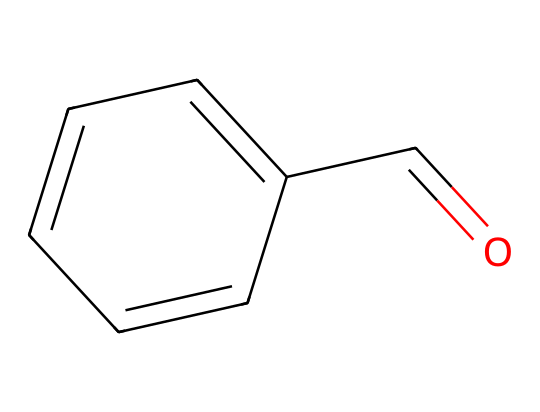What is the molecular formula of benzaldehyde? The molecular formula can be determined by counting each type of atom represented in the structure: there are 7 carbon atoms (C), 6 hydrogen atoms (H), and 1 oxygen atom (O). This gives us the molecular formula C7H6O.
Answer: C7H6O How many rings are present in the structure? The structure contains a single ring, which is indicated by the connected carbon atoms in a cyclic arrangement. In this case, the six-membered carbon ring is part of the phenyl group.
Answer: 1 What functional group is present in benzaldehyde? The carbonyl group (C=O) present in the chemical structure is indicative of the aldehyde functional group. The presence of this functional group defines benzaldehyde.
Answer: aldehyde How many double bonds are present in the molecule? By inspecting the structure, we can observe that there are two double bonds: one in the carbonyl group (C=O) and another in the carbon ring. Therefore, the total is two double bonds.
Answer: 2 Which component of the structure contributes to the artificial cherry flavor? The benzaldehyde molecule contains the aromatic ring and the aldehyde functional group, which together contribute to its sweet, cherry-like aroma in flavoring applications. Specifically, the aromatic nature and the carbonyl group play a crucial role in flavor perception.
Answer: aromatic ring and aldehyde Is benzaldehyde a saturated or unsaturated compound? The presence of double bonds in the structure indicates that it is unsaturated. Saturated compounds contain only single bonds between carbon atoms, while unsaturated compounds like benzaldehyde contain one or more double bonds.
Answer: unsaturated 